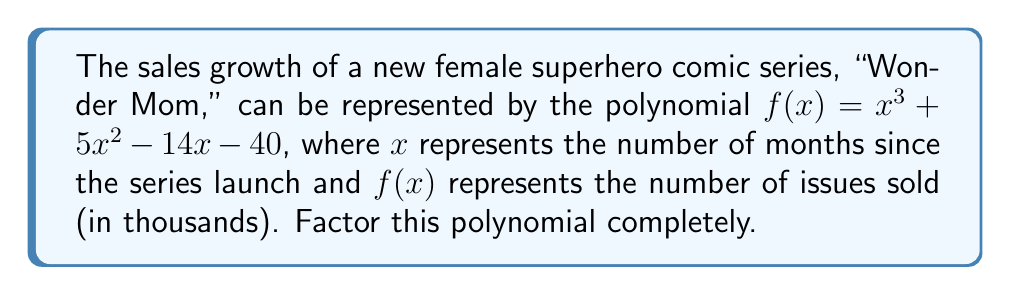Can you solve this math problem? To factor this polynomial, we'll follow these steps:

1) First, let's check if there are any common factors. In this case, there are none.

2) Next, we'll try to guess a factor. Since the constant term is -40, possible factors include ±1, ±2, ±4, ±5, ±8, ±10, ±20, ±40. Let's try these in the polynomial:

   $f(1) = 1 + 5 - 14 - 40 = -48$
   $f(-1) = -1 + 5 + 14 - 40 = -22$
   $f(2) = 8 + 20 - 28 - 40 = -40$
   $f(-2) = -8 + 20 + 28 - 40 = 0$

   We found that $f(-2) = 0$, so $(x+2)$ is a factor.

3) Divide the polynomial by $(x+2)$ using polynomial long division:

   $$\frac{x^3 + 5x^2 - 14x - 40}{x + 2} = x^2 + 3x - 20$$

4) So now we have: $f(x) = (x+2)(x^2 + 3x - 20)$

5) The quadratic factor $x^2 + 3x - 20$ can be factored further:
   
   $x^2 + 3x - 20 = (x + 8)(x - 5)$

6) Therefore, the complete factorization is:

   $f(x) = (x+2)(x+8)(x-5)$

This factorization shows that the sales will be zero when $x = -2$, $x = -8$, or $x = 5$. However, since $x$ represents months, only the positive root $x = 5$ is meaningful in this context, indicating a potential sales dip around the 5-month mark.
Answer: $f(x) = (x+2)(x+8)(x-5)$ 